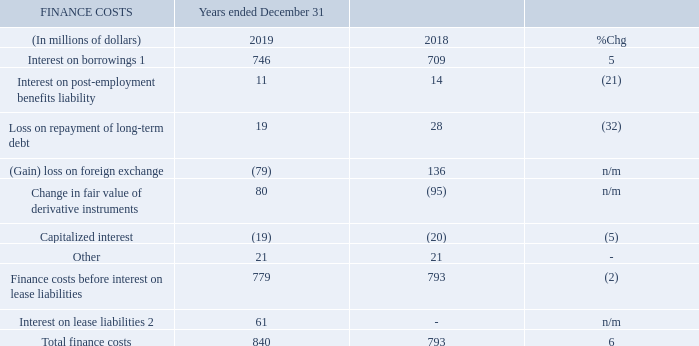1 Interest on borrowings includes interest on short-term borrowings and on long-term debt. 2 See “Accounting Policies” for more information.
The 6% increase in finance costs this year was a result of: • interest on lease liabilities as a result of our adoption of IFRS 16; and • higher outstanding debt as a result of our debt issuances in April 2019, in large part to fund our acquisition of 600 MHz spectrum licences (see “Managing Our Liquidity and Financial Resources”); partially offset by • a $21 million loss on discontinuation of hedge accounting on certain bond forward derivatives recognized in 2018.
Interest on borrowings Interest on borrowings increased this year as a result of the net issuance of senior notes throughout the year, partially offset by a higher proportion of borrowings under our lower-interest US CP program compared to 2018. See “Managing Our Liquidity and Financial Resources” for more information about our debt and related finance costs.
Loss on repayment of long-term debt This year, we recognized a $19 million loss (2018 – $28 million loss) on repayment of long-term debt, reflecting the payment of redemption premiums associated with our redemption of $900 million (2018 – US$1.4 billion) of 4.7% senior notes in November 2019 that were otherwise due in September 2020 (2018 – 6.8% senior notes in April 2018 that were otherwise due in August 2018).
Foreign exchange and change in fair value of derivative instruments We recognized $79 million in net foreign exchange gains in 2019 (2018 – $136 million in net losses). These gains and losses were primarily attributed to our US dollar-denominated commercial paper (US CP) program borrowings.
These foreign exchange gains (2018 – losses) were offset by the $80 million loss related to the change in fair value of derivatives (2018 – $95 million gain) that was primarily attributed to the debt derivatives, which were not designated as hedges for accounting purposes, we used to offset the foreign exchange risk related to these US dollar-denominated borrowings.
During the year ended December 31, 2018, we determined that we would no longer be able to exercise certain ten-year bond forward derivatives within the originally designated time frame. Consequently, we discontinued hedge accounting on those bond forward derivatives and reclassified a $21 million loss from the hedging reserve within shareholders’ equity to finance costs (recorded in “change in fair value of derivative instruments”). We subsequently extended the bond forwards to May 31, 2019, with the ability to extend them further, and redesignated them as effective hedges. During the year ended December 31, 2019, we exercised our remaining bond forwards.
See “Managing Our Liquidity and Financial Resources” for more information about our debt and related finance costs.
What were the reasons for increase in finance cost in 2019? Interest on lease liabilities as a result of our adoption of ifrs 16, higher outstanding debt as a result of our debt issuances in april 2019, in large part to fund our acquisition of 600 mhz spectrum licences (see “managing our liquidity and financial resources”); partially offset by, a $21 million loss on discontinuation of hedge accounting on certain bond forward derivatives recognized in 2018. What caused the interest on borrowings in 2019? Net issuance of senior notes throughout the year. What was the loss on repayment of long-term debt in 2019? $19 million. What was the increase / (decrease) in Interest on borrowings from 2018 to 2019?
Answer scale should be: million. 746 - 709
Answer: 37. What was the average Interest on post-employment benefits liability?
Answer scale should be: million. (11 + 14) / 2
Answer: 12.5. What was the increase / (decrease) in the Finance costs before interest on lease liabilities from 2018 to 2019?
Answer scale should be: million. 779 - 793
Answer: -14. 